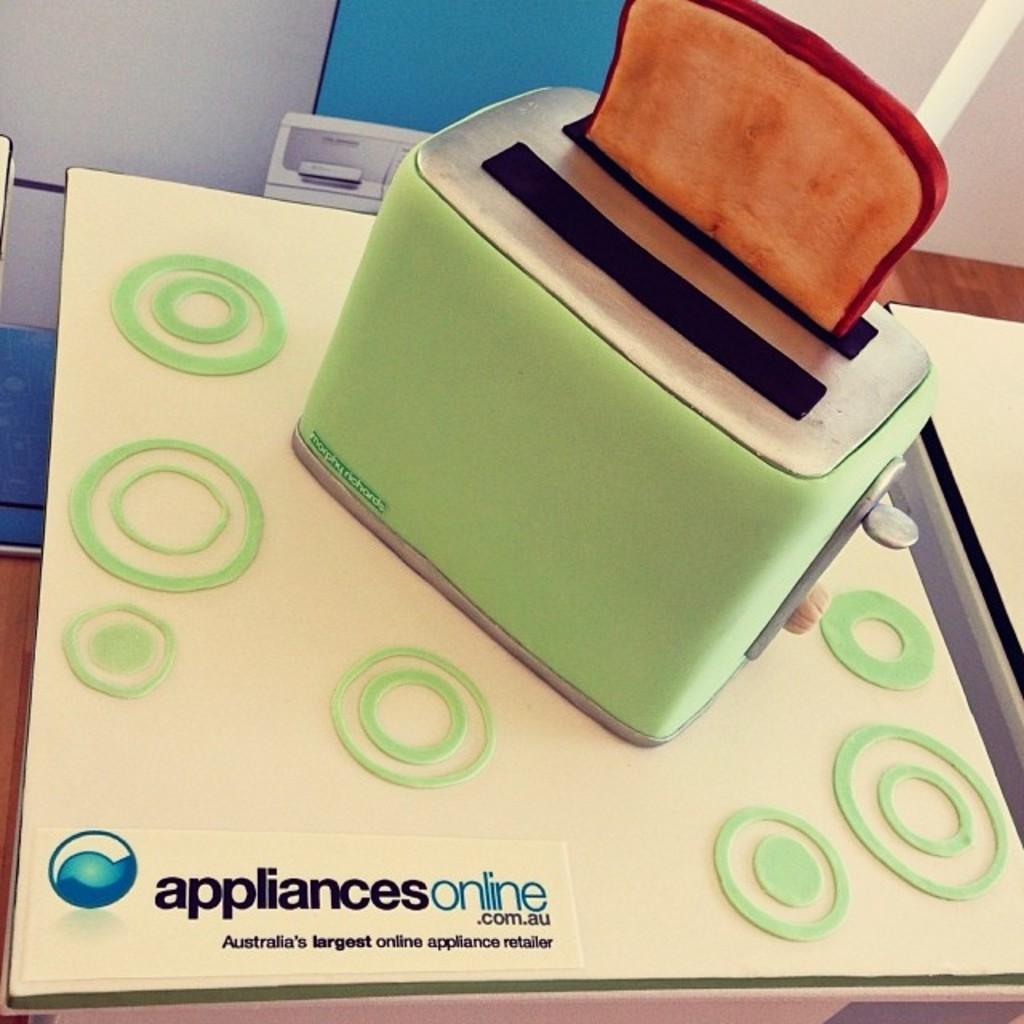Could you give a brief overview of what you see in this image? In this picture I can see there is a toaster and there is a toast in it and it placed on a surface and there is a wall in the backdrop. 